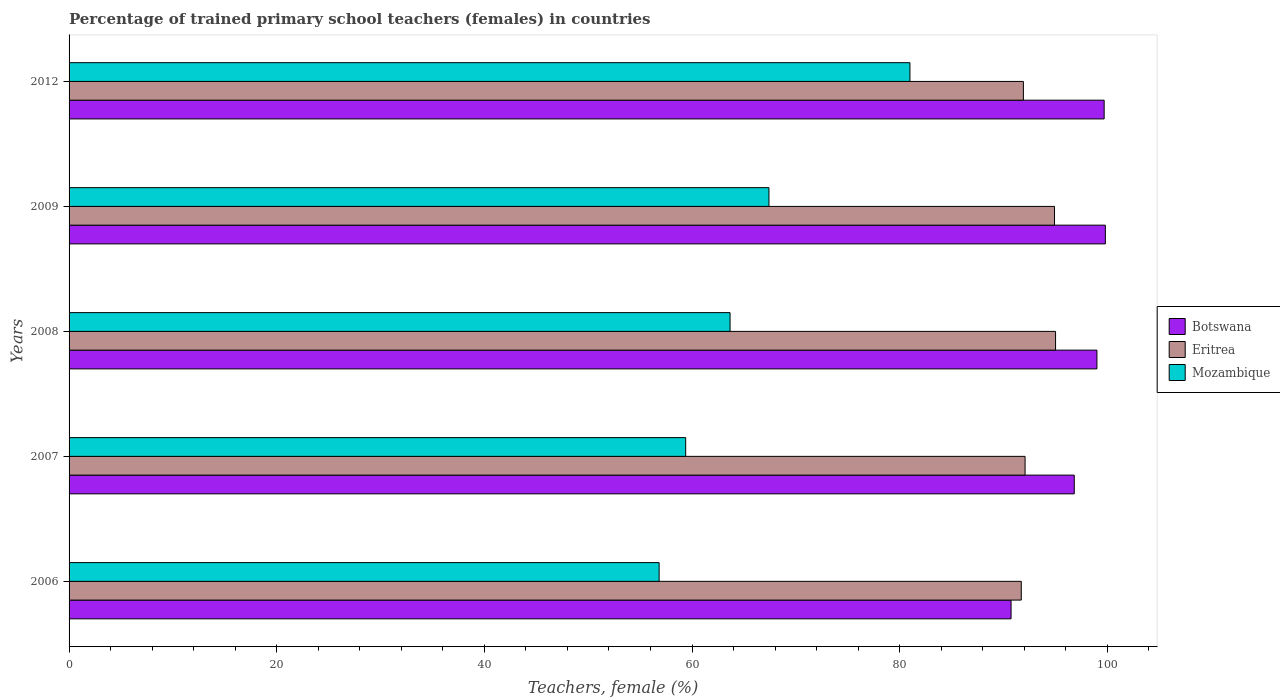How many different coloured bars are there?
Offer a terse response. 3. How many groups of bars are there?
Provide a succinct answer. 5. What is the percentage of trained primary school teachers (females) in Mozambique in 2009?
Provide a succinct answer. 67.41. Across all years, what is the maximum percentage of trained primary school teachers (females) in Eritrea?
Your answer should be compact. 95.01. Across all years, what is the minimum percentage of trained primary school teachers (females) in Eritrea?
Ensure brevity in your answer.  91.71. In which year was the percentage of trained primary school teachers (females) in Botswana maximum?
Offer a very short reply. 2009. In which year was the percentage of trained primary school teachers (females) in Eritrea minimum?
Your response must be concise. 2006. What is the total percentage of trained primary school teachers (females) in Mozambique in the graph?
Ensure brevity in your answer.  328.27. What is the difference between the percentage of trained primary school teachers (females) in Eritrea in 2008 and that in 2009?
Provide a short and direct response. 0.1. What is the difference between the percentage of trained primary school teachers (females) in Botswana in 2006 and the percentage of trained primary school teachers (females) in Eritrea in 2012?
Make the answer very short. -1.19. What is the average percentage of trained primary school teachers (females) in Mozambique per year?
Make the answer very short. 65.65. In the year 2012, what is the difference between the percentage of trained primary school teachers (females) in Eritrea and percentage of trained primary school teachers (females) in Mozambique?
Your response must be concise. 10.93. What is the ratio of the percentage of trained primary school teachers (females) in Botswana in 2007 to that in 2012?
Provide a short and direct response. 0.97. Is the percentage of trained primary school teachers (females) in Eritrea in 2007 less than that in 2009?
Make the answer very short. Yes. Is the difference between the percentage of trained primary school teachers (females) in Eritrea in 2008 and 2012 greater than the difference between the percentage of trained primary school teachers (females) in Mozambique in 2008 and 2012?
Your answer should be compact. Yes. What is the difference between the highest and the second highest percentage of trained primary school teachers (females) in Eritrea?
Offer a very short reply. 0.1. What is the difference between the highest and the lowest percentage of trained primary school teachers (females) in Eritrea?
Offer a very short reply. 3.3. In how many years, is the percentage of trained primary school teachers (females) in Eritrea greater than the average percentage of trained primary school teachers (females) in Eritrea taken over all years?
Ensure brevity in your answer.  2. What does the 3rd bar from the top in 2012 represents?
Offer a very short reply. Botswana. What does the 3rd bar from the bottom in 2006 represents?
Your response must be concise. Mozambique. Is it the case that in every year, the sum of the percentage of trained primary school teachers (females) in Botswana and percentage of trained primary school teachers (females) in Eritrea is greater than the percentage of trained primary school teachers (females) in Mozambique?
Your response must be concise. Yes. How many years are there in the graph?
Offer a terse response. 5. What is the difference between two consecutive major ticks on the X-axis?
Provide a succinct answer. 20. Are the values on the major ticks of X-axis written in scientific E-notation?
Offer a very short reply. No. How many legend labels are there?
Offer a terse response. 3. What is the title of the graph?
Provide a short and direct response. Percentage of trained primary school teachers (females) in countries. Does "Heavily indebted poor countries" appear as one of the legend labels in the graph?
Your response must be concise. No. What is the label or title of the X-axis?
Offer a very short reply. Teachers, female (%). What is the Teachers, female (%) of Botswana in 2006?
Your answer should be very brief. 90.73. What is the Teachers, female (%) in Eritrea in 2006?
Ensure brevity in your answer.  91.71. What is the Teachers, female (%) in Mozambique in 2006?
Give a very brief answer. 56.83. What is the Teachers, female (%) of Botswana in 2007?
Your answer should be compact. 96.81. What is the Teachers, female (%) in Eritrea in 2007?
Your answer should be compact. 92.08. What is the Teachers, female (%) in Mozambique in 2007?
Give a very brief answer. 59.39. What is the Teachers, female (%) of Botswana in 2008?
Your answer should be compact. 99. What is the Teachers, female (%) in Eritrea in 2008?
Ensure brevity in your answer.  95.01. What is the Teachers, female (%) of Mozambique in 2008?
Provide a short and direct response. 63.66. What is the Teachers, female (%) in Botswana in 2009?
Ensure brevity in your answer.  99.81. What is the Teachers, female (%) of Eritrea in 2009?
Give a very brief answer. 94.91. What is the Teachers, female (%) in Mozambique in 2009?
Keep it short and to the point. 67.41. What is the Teachers, female (%) in Botswana in 2012?
Make the answer very short. 99.69. What is the Teachers, female (%) in Eritrea in 2012?
Your response must be concise. 91.91. What is the Teachers, female (%) in Mozambique in 2012?
Provide a succinct answer. 80.99. Across all years, what is the maximum Teachers, female (%) in Botswana?
Provide a short and direct response. 99.81. Across all years, what is the maximum Teachers, female (%) of Eritrea?
Ensure brevity in your answer.  95.01. Across all years, what is the maximum Teachers, female (%) of Mozambique?
Give a very brief answer. 80.99. Across all years, what is the minimum Teachers, female (%) in Botswana?
Ensure brevity in your answer.  90.73. Across all years, what is the minimum Teachers, female (%) in Eritrea?
Offer a terse response. 91.71. Across all years, what is the minimum Teachers, female (%) of Mozambique?
Provide a short and direct response. 56.83. What is the total Teachers, female (%) in Botswana in the graph?
Your answer should be very brief. 486.04. What is the total Teachers, female (%) of Eritrea in the graph?
Ensure brevity in your answer.  465.62. What is the total Teachers, female (%) of Mozambique in the graph?
Offer a very short reply. 328.27. What is the difference between the Teachers, female (%) of Botswana in 2006 and that in 2007?
Make the answer very short. -6.09. What is the difference between the Teachers, female (%) of Eritrea in 2006 and that in 2007?
Give a very brief answer. -0.37. What is the difference between the Teachers, female (%) of Mozambique in 2006 and that in 2007?
Make the answer very short. -2.56. What is the difference between the Teachers, female (%) of Botswana in 2006 and that in 2008?
Your response must be concise. -8.27. What is the difference between the Teachers, female (%) of Eritrea in 2006 and that in 2008?
Provide a succinct answer. -3.3. What is the difference between the Teachers, female (%) of Mozambique in 2006 and that in 2008?
Provide a succinct answer. -6.83. What is the difference between the Teachers, female (%) in Botswana in 2006 and that in 2009?
Offer a terse response. -9.08. What is the difference between the Teachers, female (%) of Eritrea in 2006 and that in 2009?
Offer a terse response. -3.2. What is the difference between the Teachers, female (%) of Mozambique in 2006 and that in 2009?
Keep it short and to the point. -10.58. What is the difference between the Teachers, female (%) of Botswana in 2006 and that in 2012?
Ensure brevity in your answer.  -8.97. What is the difference between the Teachers, female (%) in Eritrea in 2006 and that in 2012?
Offer a terse response. -0.2. What is the difference between the Teachers, female (%) in Mozambique in 2006 and that in 2012?
Offer a terse response. -24.16. What is the difference between the Teachers, female (%) of Botswana in 2007 and that in 2008?
Offer a terse response. -2.18. What is the difference between the Teachers, female (%) in Eritrea in 2007 and that in 2008?
Your answer should be very brief. -2.94. What is the difference between the Teachers, female (%) of Mozambique in 2007 and that in 2008?
Offer a terse response. -4.27. What is the difference between the Teachers, female (%) in Botswana in 2007 and that in 2009?
Your answer should be compact. -2.99. What is the difference between the Teachers, female (%) of Eritrea in 2007 and that in 2009?
Ensure brevity in your answer.  -2.84. What is the difference between the Teachers, female (%) in Mozambique in 2007 and that in 2009?
Provide a succinct answer. -8.02. What is the difference between the Teachers, female (%) in Botswana in 2007 and that in 2012?
Your answer should be very brief. -2.88. What is the difference between the Teachers, female (%) of Eritrea in 2007 and that in 2012?
Provide a short and direct response. 0.16. What is the difference between the Teachers, female (%) of Mozambique in 2007 and that in 2012?
Offer a very short reply. -21.6. What is the difference between the Teachers, female (%) of Botswana in 2008 and that in 2009?
Your answer should be compact. -0.81. What is the difference between the Teachers, female (%) in Eritrea in 2008 and that in 2009?
Provide a succinct answer. 0.1. What is the difference between the Teachers, female (%) of Mozambique in 2008 and that in 2009?
Ensure brevity in your answer.  -3.75. What is the difference between the Teachers, female (%) of Botswana in 2008 and that in 2012?
Ensure brevity in your answer.  -0.69. What is the difference between the Teachers, female (%) in Eritrea in 2008 and that in 2012?
Your answer should be very brief. 3.1. What is the difference between the Teachers, female (%) in Mozambique in 2008 and that in 2012?
Keep it short and to the point. -17.32. What is the difference between the Teachers, female (%) in Botswana in 2009 and that in 2012?
Provide a short and direct response. 0.12. What is the difference between the Teachers, female (%) of Eritrea in 2009 and that in 2012?
Offer a very short reply. 3. What is the difference between the Teachers, female (%) in Mozambique in 2009 and that in 2012?
Offer a very short reply. -13.58. What is the difference between the Teachers, female (%) of Botswana in 2006 and the Teachers, female (%) of Eritrea in 2007?
Your response must be concise. -1.35. What is the difference between the Teachers, female (%) of Botswana in 2006 and the Teachers, female (%) of Mozambique in 2007?
Ensure brevity in your answer.  31.34. What is the difference between the Teachers, female (%) of Eritrea in 2006 and the Teachers, female (%) of Mozambique in 2007?
Offer a terse response. 32.32. What is the difference between the Teachers, female (%) in Botswana in 2006 and the Teachers, female (%) in Eritrea in 2008?
Make the answer very short. -4.29. What is the difference between the Teachers, female (%) in Botswana in 2006 and the Teachers, female (%) in Mozambique in 2008?
Your answer should be very brief. 27.06. What is the difference between the Teachers, female (%) of Eritrea in 2006 and the Teachers, female (%) of Mozambique in 2008?
Ensure brevity in your answer.  28.05. What is the difference between the Teachers, female (%) of Botswana in 2006 and the Teachers, female (%) of Eritrea in 2009?
Your response must be concise. -4.19. What is the difference between the Teachers, female (%) of Botswana in 2006 and the Teachers, female (%) of Mozambique in 2009?
Make the answer very short. 23.32. What is the difference between the Teachers, female (%) in Eritrea in 2006 and the Teachers, female (%) in Mozambique in 2009?
Keep it short and to the point. 24.3. What is the difference between the Teachers, female (%) in Botswana in 2006 and the Teachers, female (%) in Eritrea in 2012?
Ensure brevity in your answer.  -1.19. What is the difference between the Teachers, female (%) of Botswana in 2006 and the Teachers, female (%) of Mozambique in 2012?
Your answer should be very brief. 9.74. What is the difference between the Teachers, female (%) in Eritrea in 2006 and the Teachers, female (%) in Mozambique in 2012?
Offer a very short reply. 10.72. What is the difference between the Teachers, female (%) of Botswana in 2007 and the Teachers, female (%) of Eritrea in 2008?
Make the answer very short. 1.8. What is the difference between the Teachers, female (%) in Botswana in 2007 and the Teachers, female (%) in Mozambique in 2008?
Offer a very short reply. 33.15. What is the difference between the Teachers, female (%) in Eritrea in 2007 and the Teachers, female (%) in Mozambique in 2008?
Your answer should be compact. 28.41. What is the difference between the Teachers, female (%) in Botswana in 2007 and the Teachers, female (%) in Eritrea in 2009?
Provide a short and direct response. 1.9. What is the difference between the Teachers, female (%) in Botswana in 2007 and the Teachers, female (%) in Mozambique in 2009?
Give a very brief answer. 29.41. What is the difference between the Teachers, female (%) in Eritrea in 2007 and the Teachers, female (%) in Mozambique in 2009?
Your answer should be very brief. 24.67. What is the difference between the Teachers, female (%) of Botswana in 2007 and the Teachers, female (%) of Eritrea in 2012?
Provide a short and direct response. 4.9. What is the difference between the Teachers, female (%) in Botswana in 2007 and the Teachers, female (%) in Mozambique in 2012?
Make the answer very short. 15.83. What is the difference between the Teachers, female (%) in Eritrea in 2007 and the Teachers, female (%) in Mozambique in 2012?
Your response must be concise. 11.09. What is the difference between the Teachers, female (%) of Botswana in 2008 and the Teachers, female (%) of Eritrea in 2009?
Your answer should be compact. 4.08. What is the difference between the Teachers, female (%) of Botswana in 2008 and the Teachers, female (%) of Mozambique in 2009?
Provide a short and direct response. 31.59. What is the difference between the Teachers, female (%) in Eritrea in 2008 and the Teachers, female (%) in Mozambique in 2009?
Provide a succinct answer. 27.6. What is the difference between the Teachers, female (%) of Botswana in 2008 and the Teachers, female (%) of Eritrea in 2012?
Ensure brevity in your answer.  7.08. What is the difference between the Teachers, female (%) of Botswana in 2008 and the Teachers, female (%) of Mozambique in 2012?
Give a very brief answer. 18.01. What is the difference between the Teachers, female (%) in Eritrea in 2008 and the Teachers, female (%) in Mozambique in 2012?
Provide a succinct answer. 14.03. What is the difference between the Teachers, female (%) in Botswana in 2009 and the Teachers, female (%) in Eritrea in 2012?
Keep it short and to the point. 7.89. What is the difference between the Teachers, female (%) of Botswana in 2009 and the Teachers, female (%) of Mozambique in 2012?
Your answer should be compact. 18.82. What is the difference between the Teachers, female (%) in Eritrea in 2009 and the Teachers, female (%) in Mozambique in 2012?
Provide a succinct answer. 13.93. What is the average Teachers, female (%) of Botswana per year?
Provide a short and direct response. 97.21. What is the average Teachers, female (%) of Eritrea per year?
Keep it short and to the point. 93.12. What is the average Teachers, female (%) of Mozambique per year?
Offer a terse response. 65.65. In the year 2006, what is the difference between the Teachers, female (%) in Botswana and Teachers, female (%) in Eritrea?
Your answer should be very brief. -0.98. In the year 2006, what is the difference between the Teachers, female (%) of Botswana and Teachers, female (%) of Mozambique?
Offer a terse response. 33.9. In the year 2006, what is the difference between the Teachers, female (%) of Eritrea and Teachers, female (%) of Mozambique?
Ensure brevity in your answer.  34.88. In the year 2007, what is the difference between the Teachers, female (%) of Botswana and Teachers, female (%) of Eritrea?
Keep it short and to the point. 4.74. In the year 2007, what is the difference between the Teachers, female (%) of Botswana and Teachers, female (%) of Mozambique?
Give a very brief answer. 37.43. In the year 2007, what is the difference between the Teachers, female (%) of Eritrea and Teachers, female (%) of Mozambique?
Give a very brief answer. 32.69. In the year 2008, what is the difference between the Teachers, female (%) of Botswana and Teachers, female (%) of Eritrea?
Offer a terse response. 3.98. In the year 2008, what is the difference between the Teachers, female (%) in Botswana and Teachers, female (%) in Mozambique?
Give a very brief answer. 35.34. In the year 2008, what is the difference between the Teachers, female (%) in Eritrea and Teachers, female (%) in Mozambique?
Ensure brevity in your answer.  31.35. In the year 2009, what is the difference between the Teachers, female (%) of Botswana and Teachers, female (%) of Eritrea?
Provide a short and direct response. 4.9. In the year 2009, what is the difference between the Teachers, female (%) in Botswana and Teachers, female (%) in Mozambique?
Make the answer very short. 32.4. In the year 2009, what is the difference between the Teachers, female (%) in Eritrea and Teachers, female (%) in Mozambique?
Provide a succinct answer. 27.5. In the year 2012, what is the difference between the Teachers, female (%) in Botswana and Teachers, female (%) in Eritrea?
Your answer should be compact. 7.78. In the year 2012, what is the difference between the Teachers, female (%) of Botswana and Teachers, female (%) of Mozambique?
Offer a terse response. 18.71. In the year 2012, what is the difference between the Teachers, female (%) of Eritrea and Teachers, female (%) of Mozambique?
Your answer should be compact. 10.93. What is the ratio of the Teachers, female (%) of Botswana in 2006 to that in 2007?
Provide a short and direct response. 0.94. What is the ratio of the Teachers, female (%) of Mozambique in 2006 to that in 2007?
Your response must be concise. 0.96. What is the ratio of the Teachers, female (%) in Botswana in 2006 to that in 2008?
Offer a very short reply. 0.92. What is the ratio of the Teachers, female (%) of Eritrea in 2006 to that in 2008?
Provide a succinct answer. 0.97. What is the ratio of the Teachers, female (%) in Mozambique in 2006 to that in 2008?
Offer a terse response. 0.89. What is the ratio of the Teachers, female (%) in Botswana in 2006 to that in 2009?
Offer a terse response. 0.91. What is the ratio of the Teachers, female (%) in Eritrea in 2006 to that in 2009?
Offer a terse response. 0.97. What is the ratio of the Teachers, female (%) in Mozambique in 2006 to that in 2009?
Offer a terse response. 0.84. What is the ratio of the Teachers, female (%) of Botswana in 2006 to that in 2012?
Ensure brevity in your answer.  0.91. What is the ratio of the Teachers, female (%) of Mozambique in 2006 to that in 2012?
Keep it short and to the point. 0.7. What is the ratio of the Teachers, female (%) of Botswana in 2007 to that in 2008?
Provide a short and direct response. 0.98. What is the ratio of the Teachers, female (%) in Eritrea in 2007 to that in 2008?
Ensure brevity in your answer.  0.97. What is the ratio of the Teachers, female (%) in Mozambique in 2007 to that in 2008?
Make the answer very short. 0.93. What is the ratio of the Teachers, female (%) in Eritrea in 2007 to that in 2009?
Keep it short and to the point. 0.97. What is the ratio of the Teachers, female (%) in Mozambique in 2007 to that in 2009?
Make the answer very short. 0.88. What is the ratio of the Teachers, female (%) of Botswana in 2007 to that in 2012?
Keep it short and to the point. 0.97. What is the ratio of the Teachers, female (%) in Eritrea in 2007 to that in 2012?
Provide a short and direct response. 1. What is the ratio of the Teachers, female (%) in Mozambique in 2007 to that in 2012?
Give a very brief answer. 0.73. What is the ratio of the Teachers, female (%) of Botswana in 2008 to that in 2012?
Offer a terse response. 0.99. What is the ratio of the Teachers, female (%) of Eritrea in 2008 to that in 2012?
Ensure brevity in your answer.  1.03. What is the ratio of the Teachers, female (%) of Mozambique in 2008 to that in 2012?
Offer a terse response. 0.79. What is the ratio of the Teachers, female (%) in Botswana in 2009 to that in 2012?
Offer a terse response. 1. What is the ratio of the Teachers, female (%) of Eritrea in 2009 to that in 2012?
Provide a succinct answer. 1.03. What is the ratio of the Teachers, female (%) of Mozambique in 2009 to that in 2012?
Your response must be concise. 0.83. What is the difference between the highest and the second highest Teachers, female (%) of Botswana?
Keep it short and to the point. 0.12. What is the difference between the highest and the second highest Teachers, female (%) in Eritrea?
Give a very brief answer. 0.1. What is the difference between the highest and the second highest Teachers, female (%) of Mozambique?
Ensure brevity in your answer.  13.58. What is the difference between the highest and the lowest Teachers, female (%) in Botswana?
Offer a terse response. 9.08. What is the difference between the highest and the lowest Teachers, female (%) in Eritrea?
Your response must be concise. 3.3. What is the difference between the highest and the lowest Teachers, female (%) in Mozambique?
Offer a terse response. 24.16. 